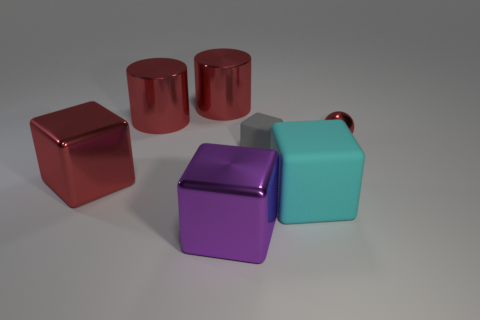Are any gray rubber things visible?
Your response must be concise. Yes. How many large things are either purple metal cubes or cyan things?
Offer a very short reply. 2. Are there any other things that have the same color as the tiny matte thing?
Offer a terse response. No. The other tiny object that is made of the same material as the purple object is what shape?
Provide a succinct answer. Sphere. There is a red object on the right side of the big matte block; what is its size?
Provide a short and direct response. Small. The big purple object is what shape?
Make the answer very short. Cube. Is the size of the matte block in front of the gray block the same as the metallic block left of the purple thing?
Keep it short and to the point. Yes. There is a matte cube in front of the red thing in front of the red metallic thing on the right side of the purple shiny block; what size is it?
Make the answer very short. Large. What is the shape of the red metal object in front of the red metal object that is on the right side of the small thing in front of the small red sphere?
Offer a terse response. Cube. There is a small object to the left of the small red sphere; what is its shape?
Give a very brief answer. Cube. 